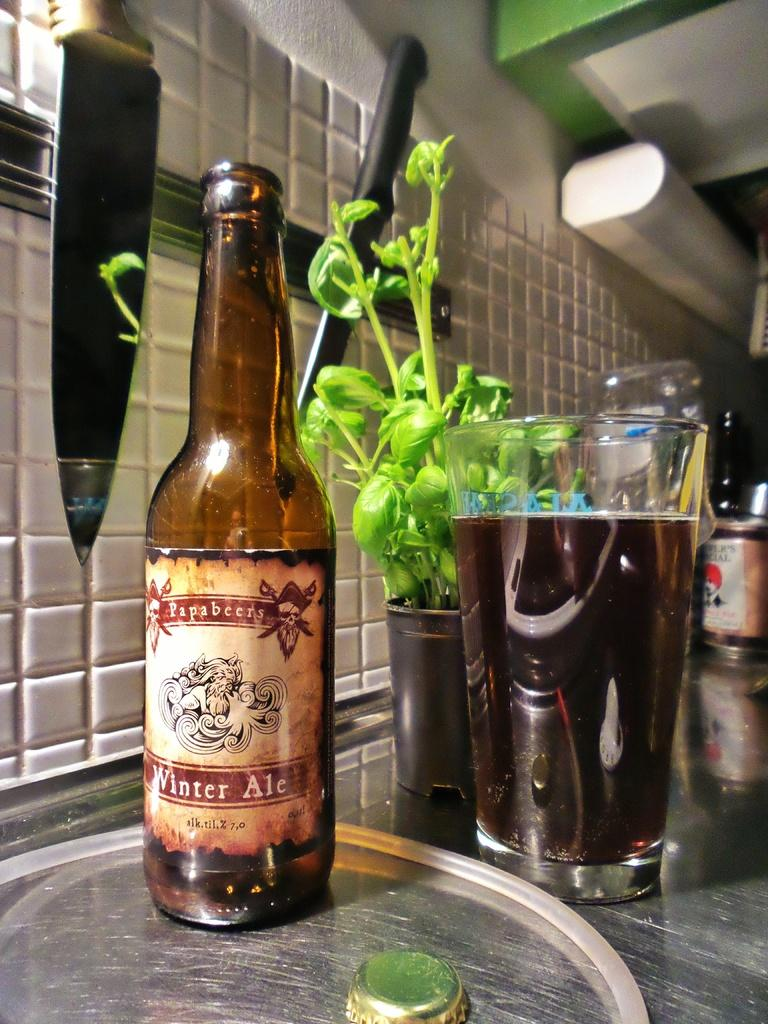What objects can be seen in the image? There are glasses and a bottle in the image. Can you describe the glasses in the image? The glasses are the main objects visible in the image. What is the other object present in the image? There is a bottle in the image. How many girls are playing with the bomb in the image? There are no girls or bombs present in the image. What type of farmer is shown working in the image? There is no farmer present in the image. 